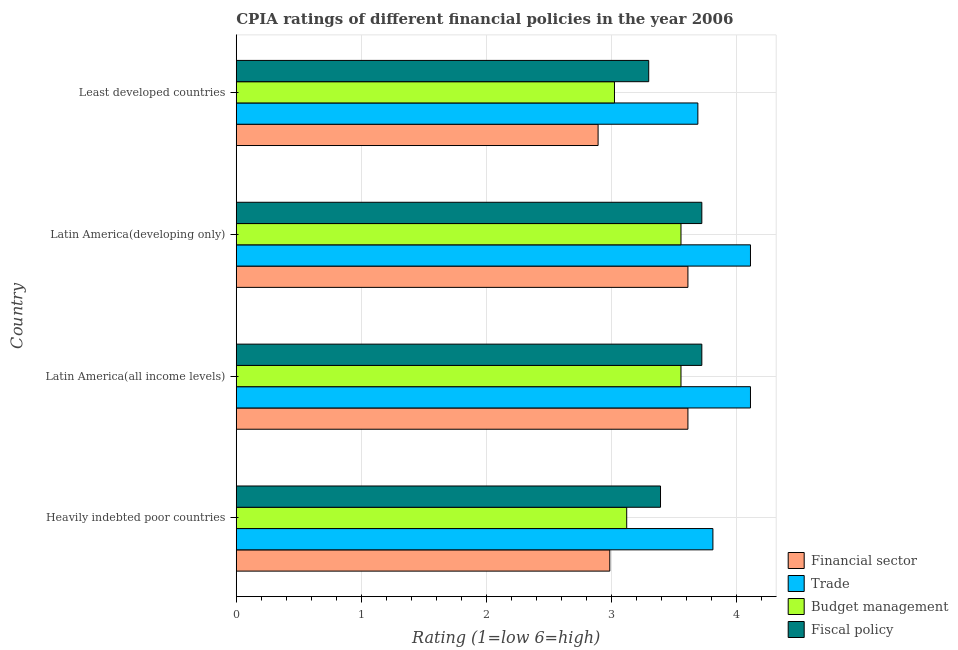How many bars are there on the 4th tick from the top?
Ensure brevity in your answer.  4. What is the label of the 3rd group of bars from the top?
Your answer should be compact. Latin America(all income levels). In how many cases, is the number of bars for a given country not equal to the number of legend labels?
Offer a terse response. 0. What is the cpia rating of trade in Heavily indebted poor countries?
Ensure brevity in your answer.  3.81. Across all countries, what is the maximum cpia rating of fiscal policy?
Your response must be concise. 3.72. Across all countries, what is the minimum cpia rating of financial sector?
Your response must be concise. 2.89. In which country was the cpia rating of trade maximum?
Your answer should be compact. Latin America(all income levels). In which country was the cpia rating of trade minimum?
Provide a succinct answer. Least developed countries. What is the total cpia rating of budget management in the graph?
Give a very brief answer. 13.26. What is the difference between the cpia rating of budget management in Heavily indebted poor countries and that in Latin America(developing only)?
Provide a succinct answer. -0.43. What is the difference between the cpia rating of fiscal policy in Least developed countries and the cpia rating of trade in Heavily indebted poor countries?
Your response must be concise. -0.51. What is the average cpia rating of financial sector per country?
Provide a short and direct response. 3.27. What is the difference between the cpia rating of financial sector and cpia rating of budget management in Latin America(all income levels)?
Give a very brief answer. 0.06. What is the ratio of the cpia rating of trade in Heavily indebted poor countries to that in Latin America(developing only)?
Ensure brevity in your answer.  0.93. Is the difference between the cpia rating of trade in Latin America(all income levels) and Least developed countries greater than the difference between the cpia rating of fiscal policy in Latin America(all income levels) and Least developed countries?
Your answer should be compact. No. What is the difference between the highest and the lowest cpia rating of trade?
Make the answer very short. 0.42. What does the 2nd bar from the top in Latin America(all income levels) represents?
Your answer should be compact. Budget management. What does the 1st bar from the bottom in Least developed countries represents?
Ensure brevity in your answer.  Financial sector. What is the difference between two consecutive major ticks on the X-axis?
Offer a very short reply. 1. Are the values on the major ticks of X-axis written in scientific E-notation?
Ensure brevity in your answer.  No. Does the graph contain any zero values?
Keep it short and to the point. No. Does the graph contain grids?
Ensure brevity in your answer.  Yes. How are the legend labels stacked?
Your answer should be compact. Vertical. What is the title of the graph?
Make the answer very short. CPIA ratings of different financial policies in the year 2006. Does "Water" appear as one of the legend labels in the graph?
Offer a very short reply. No. What is the label or title of the Y-axis?
Make the answer very short. Country. What is the Rating (1=low 6=high) of Financial sector in Heavily indebted poor countries?
Give a very brief answer. 2.99. What is the Rating (1=low 6=high) of Trade in Heavily indebted poor countries?
Provide a short and direct response. 3.81. What is the Rating (1=low 6=high) of Budget management in Heavily indebted poor countries?
Keep it short and to the point. 3.12. What is the Rating (1=low 6=high) in Fiscal policy in Heavily indebted poor countries?
Provide a short and direct response. 3.39. What is the Rating (1=low 6=high) in Financial sector in Latin America(all income levels)?
Give a very brief answer. 3.61. What is the Rating (1=low 6=high) of Trade in Latin America(all income levels)?
Your answer should be compact. 4.11. What is the Rating (1=low 6=high) in Budget management in Latin America(all income levels)?
Provide a short and direct response. 3.56. What is the Rating (1=low 6=high) in Fiscal policy in Latin America(all income levels)?
Provide a short and direct response. 3.72. What is the Rating (1=low 6=high) of Financial sector in Latin America(developing only)?
Offer a terse response. 3.61. What is the Rating (1=low 6=high) in Trade in Latin America(developing only)?
Offer a very short reply. 4.11. What is the Rating (1=low 6=high) in Budget management in Latin America(developing only)?
Keep it short and to the point. 3.56. What is the Rating (1=low 6=high) of Fiscal policy in Latin America(developing only)?
Your response must be concise. 3.72. What is the Rating (1=low 6=high) in Financial sector in Least developed countries?
Give a very brief answer. 2.89. What is the Rating (1=low 6=high) of Trade in Least developed countries?
Your response must be concise. 3.69. What is the Rating (1=low 6=high) of Budget management in Least developed countries?
Offer a very short reply. 3.02. What is the Rating (1=low 6=high) in Fiscal policy in Least developed countries?
Provide a short and direct response. 3.3. Across all countries, what is the maximum Rating (1=low 6=high) in Financial sector?
Provide a short and direct response. 3.61. Across all countries, what is the maximum Rating (1=low 6=high) in Trade?
Your response must be concise. 4.11. Across all countries, what is the maximum Rating (1=low 6=high) in Budget management?
Your answer should be very brief. 3.56. Across all countries, what is the maximum Rating (1=low 6=high) in Fiscal policy?
Your response must be concise. 3.72. Across all countries, what is the minimum Rating (1=low 6=high) in Financial sector?
Your answer should be very brief. 2.89. Across all countries, what is the minimum Rating (1=low 6=high) of Trade?
Make the answer very short. 3.69. Across all countries, what is the minimum Rating (1=low 6=high) in Budget management?
Your answer should be compact. 3.02. Across all countries, what is the minimum Rating (1=low 6=high) of Fiscal policy?
Keep it short and to the point. 3.3. What is the total Rating (1=low 6=high) in Financial sector in the graph?
Your answer should be very brief. 13.1. What is the total Rating (1=low 6=high) in Trade in the graph?
Offer a terse response. 15.72. What is the total Rating (1=low 6=high) of Budget management in the graph?
Offer a very short reply. 13.26. What is the total Rating (1=low 6=high) of Fiscal policy in the graph?
Make the answer very short. 14.13. What is the difference between the Rating (1=low 6=high) in Financial sector in Heavily indebted poor countries and that in Latin America(all income levels)?
Offer a terse response. -0.62. What is the difference between the Rating (1=low 6=high) in Trade in Heavily indebted poor countries and that in Latin America(all income levels)?
Provide a short and direct response. -0.3. What is the difference between the Rating (1=low 6=high) of Budget management in Heavily indebted poor countries and that in Latin America(all income levels)?
Your response must be concise. -0.43. What is the difference between the Rating (1=low 6=high) in Fiscal policy in Heavily indebted poor countries and that in Latin America(all income levels)?
Keep it short and to the point. -0.33. What is the difference between the Rating (1=low 6=high) of Financial sector in Heavily indebted poor countries and that in Latin America(developing only)?
Your response must be concise. -0.62. What is the difference between the Rating (1=low 6=high) of Trade in Heavily indebted poor countries and that in Latin America(developing only)?
Your answer should be very brief. -0.3. What is the difference between the Rating (1=low 6=high) of Budget management in Heavily indebted poor countries and that in Latin America(developing only)?
Provide a short and direct response. -0.43. What is the difference between the Rating (1=low 6=high) in Fiscal policy in Heavily indebted poor countries and that in Latin America(developing only)?
Offer a very short reply. -0.33. What is the difference between the Rating (1=low 6=high) of Financial sector in Heavily indebted poor countries and that in Least developed countries?
Keep it short and to the point. 0.09. What is the difference between the Rating (1=low 6=high) in Trade in Heavily indebted poor countries and that in Least developed countries?
Give a very brief answer. 0.12. What is the difference between the Rating (1=low 6=high) of Budget management in Heavily indebted poor countries and that in Least developed countries?
Provide a short and direct response. 0.1. What is the difference between the Rating (1=low 6=high) of Fiscal policy in Heavily indebted poor countries and that in Least developed countries?
Make the answer very short. 0.09. What is the difference between the Rating (1=low 6=high) of Financial sector in Latin America(all income levels) and that in Latin America(developing only)?
Make the answer very short. 0. What is the difference between the Rating (1=low 6=high) in Trade in Latin America(all income levels) and that in Latin America(developing only)?
Ensure brevity in your answer.  0. What is the difference between the Rating (1=low 6=high) in Budget management in Latin America(all income levels) and that in Latin America(developing only)?
Your answer should be very brief. 0. What is the difference between the Rating (1=low 6=high) in Financial sector in Latin America(all income levels) and that in Least developed countries?
Make the answer very short. 0.72. What is the difference between the Rating (1=low 6=high) in Trade in Latin America(all income levels) and that in Least developed countries?
Ensure brevity in your answer.  0.42. What is the difference between the Rating (1=low 6=high) of Budget management in Latin America(all income levels) and that in Least developed countries?
Your answer should be compact. 0.53. What is the difference between the Rating (1=low 6=high) of Fiscal policy in Latin America(all income levels) and that in Least developed countries?
Make the answer very short. 0.42. What is the difference between the Rating (1=low 6=high) in Financial sector in Latin America(developing only) and that in Least developed countries?
Keep it short and to the point. 0.72. What is the difference between the Rating (1=low 6=high) of Trade in Latin America(developing only) and that in Least developed countries?
Offer a very short reply. 0.42. What is the difference between the Rating (1=low 6=high) of Budget management in Latin America(developing only) and that in Least developed countries?
Keep it short and to the point. 0.53. What is the difference between the Rating (1=low 6=high) in Fiscal policy in Latin America(developing only) and that in Least developed countries?
Your answer should be very brief. 0.42. What is the difference between the Rating (1=low 6=high) of Financial sector in Heavily indebted poor countries and the Rating (1=low 6=high) of Trade in Latin America(all income levels)?
Your response must be concise. -1.12. What is the difference between the Rating (1=low 6=high) in Financial sector in Heavily indebted poor countries and the Rating (1=low 6=high) in Budget management in Latin America(all income levels)?
Offer a terse response. -0.57. What is the difference between the Rating (1=low 6=high) in Financial sector in Heavily indebted poor countries and the Rating (1=low 6=high) in Fiscal policy in Latin America(all income levels)?
Provide a short and direct response. -0.74. What is the difference between the Rating (1=low 6=high) in Trade in Heavily indebted poor countries and the Rating (1=low 6=high) in Budget management in Latin America(all income levels)?
Give a very brief answer. 0.26. What is the difference between the Rating (1=low 6=high) in Trade in Heavily indebted poor countries and the Rating (1=low 6=high) in Fiscal policy in Latin America(all income levels)?
Make the answer very short. 0.09. What is the difference between the Rating (1=low 6=high) in Budget management in Heavily indebted poor countries and the Rating (1=low 6=high) in Fiscal policy in Latin America(all income levels)?
Offer a very short reply. -0.6. What is the difference between the Rating (1=low 6=high) in Financial sector in Heavily indebted poor countries and the Rating (1=low 6=high) in Trade in Latin America(developing only)?
Make the answer very short. -1.12. What is the difference between the Rating (1=low 6=high) in Financial sector in Heavily indebted poor countries and the Rating (1=low 6=high) in Budget management in Latin America(developing only)?
Your response must be concise. -0.57. What is the difference between the Rating (1=low 6=high) of Financial sector in Heavily indebted poor countries and the Rating (1=low 6=high) of Fiscal policy in Latin America(developing only)?
Provide a succinct answer. -0.74. What is the difference between the Rating (1=low 6=high) of Trade in Heavily indebted poor countries and the Rating (1=low 6=high) of Budget management in Latin America(developing only)?
Your response must be concise. 0.26. What is the difference between the Rating (1=low 6=high) of Trade in Heavily indebted poor countries and the Rating (1=low 6=high) of Fiscal policy in Latin America(developing only)?
Ensure brevity in your answer.  0.09. What is the difference between the Rating (1=low 6=high) of Budget management in Heavily indebted poor countries and the Rating (1=low 6=high) of Fiscal policy in Latin America(developing only)?
Keep it short and to the point. -0.6. What is the difference between the Rating (1=low 6=high) in Financial sector in Heavily indebted poor countries and the Rating (1=low 6=high) in Trade in Least developed countries?
Your answer should be very brief. -0.7. What is the difference between the Rating (1=low 6=high) of Financial sector in Heavily indebted poor countries and the Rating (1=low 6=high) of Budget management in Least developed countries?
Provide a succinct answer. -0.04. What is the difference between the Rating (1=low 6=high) of Financial sector in Heavily indebted poor countries and the Rating (1=low 6=high) of Fiscal policy in Least developed countries?
Give a very brief answer. -0.31. What is the difference between the Rating (1=low 6=high) in Trade in Heavily indebted poor countries and the Rating (1=low 6=high) in Budget management in Least developed countries?
Your response must be concise. 0.79. What is the difference between the Rating (1=low 6=high) of Trade in Heavily indebted poor countries and the Rating (1=low 6=high) of Fiscal policy in Least developed countries?
Provide a succinct answer. 0.51. What is the difference between the Rating (1=low 6=high) of Budget management in Heavily indebted poor countries and the Rating (1=low 6=high) of Fiscal policy in Least developed countries?
Provide a succinct answer. -0.18. What is the difference between the Rating (1=low 6=high) in Financial sector in Latin America(all income levels) and the Rating (1=low 6=high) in Trade in Latin America(developing only)?
Your answer should be compact. -0.5. What is the difference between the Rating (1=low 6=high) of Financial sector in Latin America(all income levels) and the Rating (1=low 6=high) of Budget management in Latin America(developing only)?
Your response must be concise. 0.06. What is the difference between the Rating (1=low 6=high) in Financial sector in Latin America(all income levels) and the Rating (1=low 6=high) in Fiscal policy in Latin America(developing only)?
Offer a very short reply. -0.11. What is the difference between the Rating (1=low 6=high) of Trade in Latin America(all income levels) and the Rating (1=low 6=high) of Budget management in Latin America(developing only)?
Provide a short and direct response. 0.56. What is the difference between the Rating (1=low 6=high) in Trade in Latin America(all income levels) and the Rating (1=low 6=high) in Fiscal policy in Latin America(developing only)?
Your answer should be very brief. 0.39. What is the difference between the Rating (1=low 6=high) of Financial sector in Latin America(all income levels) and the Rating (1=low 6=high) of Trade in Least developed countries?
Your response must be concise. -0.08. What is the difference between the Rating (1=low 6=high) of Financial sector in Latin America(all income levels) and the Rating (1=low 6=high) of Budget management in Least developed countries?
Keep it short and to the point. 0.59. What is the difference between the Rating (1=low 6=high) in Financial sector in Latin America(all income levels) and the Rating (1=low 6=high) in Fiscal policy in Least developed countries?
Your response must be concise. 0.31. What is the difference between the Rating (1=low 6=high) of Trade in Latin America(all income levels) and the Rating (1=low 6=high) of Budget management in Least developed countries?
Offer a very short reply. 1.09. What is the difference between the Rating (1=low 6=high) of Trade in Latin America(all income levels) and the Rating (1=low 6=high) of Fiscal policy in Least developed countries?
Offer a very short reply. 0.81. What is the difference between the Rating (1=low 6=high) in Budget management in Latin America(all income levels) and the Rating (1=low 6=high) in Fiscal policy in Least developed countries?
Provide a short and direct response. 0.26. What is the difference between the Rating (1=low 6=high) of Financial sector in Latin America(developing only) and the Rating (1=low 6=high) of Trade in Least developed countries?
Ensure brevity in your answer.  -0.08. What is the difference between the Rating (1=low 6=high) in Financial sector in Latin America(developing only) and the Rating (1=low 6=high) in Budget management in Least developed countries?
Offer a very short reply. 0.59. What is the difference between the Rating (1=low 6=high) of Financial sector in Latin America(developing only) and the Rating (1=low 6=high) of Fiscal policy in Least developed countries?
Your answer should be very brief. 0.31. What is the difference between the Rating (1=low 6=high) of Trade in Latin America(developing only) and the Rating (1=low 6=high) of Budget management in Least developed countries?
Provide a succinct answer. 1.09. What is the difference between the Rating (1=low 6=high) in Trade in Latin America(developing only) and the Rating (1=low 6=high) in Fiscal policy in Least developed countries?
Provide a succinct answer. 0.81. What is the difference between the Rating (1=low 6=high) in Budget management in Latin America(developing only) and the Rating (1=low 6=high) in Fiscal policy in Least developed countries?
Your answer should be compact. 0.26. What is the average Rating (1=low 6=high) in Financial sector per country?
Give a very brief answer. 3.28. What is the average Rating (1=low 6=high) in Trade per country?
Offer a very short reply. 3.93. What is the average Rating (1=low 6=high) of Budget management per country?
Give a very brief answer. 3.31. What is the average Rating (1=low 6=high) in Fiscal policy per country?
Your answer should be very brief. 3.53. What is the difference between the Rating (1=low 6=high) in Financial sector and Rating (1=low 6=high) in Trade in Heavily indebted poor countries?
Your answer should be very brief. -0.82. What is the difference between the Rating (1=low 6=high) in Financial sector and Rating (1=low 6=high) in Budget management in Heavily indebted poor countries?
Make the answer very short. -0.14. What is the difference between the Rating (1=low 6=high) of Financial sector and Rating (1=low 6=high) of Fiscal policy in Heavily indebted poor countries?
Provide a succinct answer. -0.41. What is the difference between the Rating (1=low 6=high) of Trade and Rating (1=low 6=high) of Budget management in Heavily indebted poor countries?
Your answer should be very brief. 0.69. What is the difference between the Rating (1=low 6=high) of Trade and Rating (1=low 6=high) of Fiscal policy in Heavily indebted poor countries?
Offer a very short reply. 0.42. What is the difference between the Rating (1=low 6=high) of Budget management and Rating (1=low 6=high) of Fiscal policy in Heavily indebted poor countries?
Ensure brevity in your answer.  -0.27. What is the difference between the Rating (1=low 6=high) of Financial sector and Rating (1=low 6=high) of Trade in Latin America(all income levels)?
Make the answer very short. -0.5. What is the difference between the Rating (1=low 6=high) in Financial sector and Rating (1=low 6=high) in Budget management in Latin America(all income levels)?
Ensure brevity in your answer.  0.06. What is the difference between the Rating (1=low 6=high) in Financial sector and Rating (1=low 6=high) in Fiscal policy in Latin America(all income levels)?
Make the answer very short. -0.11. What is the difference between the Rating (1=low 6=high) of Trade and Rating (1=low 6=high) of Budget management in Latin America(all income levels)?
Keep it short and to the point. 0.56. What is the difference between the Rating (1=low 6=high) in Trade and Rating (1=low 6=high) in Fiscal policy in Latin America(all income levels)?
Provide a short and direct response. 0.39. What is the difference between the Rating (1=low 6=high) in Budget management and Rating (1=low 6=high) in Fiscal policy in Latin America(all income levels)?
Ensure brevity in your answer.  -0.17. What is the difference between the Rating (1=low 6=high) of Financial sector and Rating (1=low 6=high) of Trade in Latin America(developing only)?
Provide a short and direct response. -0.5. What is the difference between the Rating (1=low 6=high) in Financial sector and Rating (1=low 6=high) in Budget management in Latin America(developing only)?
Give a very brief answer. 0.06. What is the difference between the Rating (1=low 6=high) in Financial sector and Rating (1=low 6=high) in Fiscal policy in Latin America(developing only)?
Give a very brief answer. -0.11. What is the difference between the Rating (1=low 6=high) in Trade and Rating (1=low 6=high) in Budget management in Latin America(developing only)?
Provide a short and direct response. 0.56. What is the difference between the Rating (1=low 6=high) in Trade and Rating (1=low 6=high) in Fiscal policy in Latin America(developing only)?
Ensure brevity in your answer.  0.39. What is the difference between the Rating (1=low 6=high) of Budget management and Rating (1=low 6=high) of Fiscal policy in Latin America(developing only)?
Give a very brief answer. -0.17. What is the difference between the Rating (1=low 6=high) in Financial sector and Rating (1=low 6=high) in Trade in Least developed countries?
Make the answer very short. -0.8. What is the difference between the Rating (1=low 6=high) in Financial sector and Rating (1=low 6=high) in Budget management in Least developed countries?
Make the answer very short. -0.13. What is the difference between the Rating (1=low 6=high) of Financial sector and Rating (1=low 6=high) of Fiscal policy in Least developed countries?
Provide a short and direct response. -0.4. What is the difference between the Rating (1=low 6=high) in Trade and Rating (1=low 6=high) in Fiscal policy in Least developed countries?
Your answer should be compact. 0.39. What is the difference between the Rating (1=low 6=high) in Budget management and Rating (1=low 6=high) in Fiscal policy in Least developed countries?
Provide a short and direct response. -0.27. What is the ratio of the Rating (1=low 6=high) in Financial sector in Heavily indebted poor countries to that in Latin America(all income levels)?
Your response must be concise. 0.83. What is the ratio of the Rating (1=low 6=high) of Trade in Heavily indebted poor countries to that in Latin America(all income levels)?
Your answer should be compact. 0.93. What is the ratio of the Rating (1=low 6=high) in Budget management in Heavily indebted poor countries to that in Latin America(all income levels)?
Keep it short and to the point. 0.88. What is the ratio of the Rating (1=low 6=high) in Fiscal policy in Heavily indebted poor countries to that in Latin America(all income levels)?
Provide a succinct answer. 0.91. What is the ratio of the Rating (1=low 6=high) of Financial sector in Heavily indebted poor countries to that in Latin America(developing only)?
Your answer should be compact. 0.83. What is the ratio of the Rating (1=low 6=high) in Trade in Heavily indebted poor countries to that in Latin America(developing only)?
Keep it short and to the point. 0.93. What is the ratio of the Rating (1=low 6=high) of Budget management in Heavily indebted poor countries to that in Latin America(developing only)?
Keep it short and to the point. 0.88. What is the ratio of the Rating (1=low 6=high) of Fiscal policy in Heavily indebted poor countries to that in Latin America(developing only)?
Provide a succinct answer. 0.91. What is the ratio of the Rating (1=low 6=high) of Financial sector in Heavily indebted poor countries to that in Least developed countries?
Your response must be concise. 1.03. What is the ratio of the Rating (1=low 6=high) of Trade in Heavily indebted poor countries to that in Least developed countries?
Offer a terse response. 1.03. What is the ratio of the Rating (1=low 6=high) of Budget management in Heavily indebted poor countries to that in Least developed countries?
Offer a very short reply. 1.03. What is the ratio of the Rating (1=low 6=high) in Fiscal policy in Heavily indebted poor countries to that in Least developed countries?
Your response must be concise. 1.03. What is the ratio of the Rating (1=low 6=high) in Financial sector in Latin America(all income levels) to that in Latin America(developing only)?
Offer a terse response. 1. What is the ratio of the Rating (1=low 6=high) in Trade in Latin America(all income levels) to that in Latin America(developing only)?
Provide a short and direct response. 1. What is the ratio of the Rating (1=low 6=high) of Fiscal policy in Latin America(all income levels) to that in Latin America(developing only)?
Your answer should be compact. 1. What is the ratio of the Rating (1=low 6=high) of Financial sector in Latin America(all income levels) to that in Least developed countries?
Make the answer very short. 1.25. What is the ratio of the Rating (1=low 6=high) of Trade in Latin America(all income levels) to that in Least developed countries?
Provide a short and direct response. 1.11. What is the ratio of the Rating (1=low 6=high) in Budget management in Latin America(all income levels) to that in Least developed countries?
Give a very brief answer. 1.18. What is the ratio of the Rating (1=low 6=high) in Fiscal policy in Latin America(all income levels) to that in Least developed countries?
Your answer should be very brief. 1.13. What is the ratio of the Rating (1=low 6=high) in Financial sector in Latin America(developing only) to that in Least developed countries?
Keep it short and to the point. 1.25. What is the ratio of the Rating (1=low 6=high) in Trade in Latin America(developing only) to that in Least developed countries?
Provide a short and direct response. 1.11. What is the ratio of the Rating (1=low 6=high) of Budget management in Latin America(developing only) to that in Least developed countries?
Provide a succinct answer. 1.18. What is the ratio of the Rating (1=low 6=high) in Fiscal policy in Latin America(developing only) to that in Least developed countries?
Your answer should be very brief. 1.13. What is the difference between the highest and the second highest Rating (1=low 6=high) of Trade?
Keep it short and to the point. 0. What is the difference between the highest and the second highest Rating (1=low 6=high) in Budget management?
Your answer should be very brief. 0. What is the difference between the highest and the lowest Rating (1=low 6=high) of Financial sector?
Offer a very short reply. 0.72. What is the difference between the highest and the lowest Rating (1=low 6=high) in Trade?
Provide a succinct answer. 0.42. What is the difference between the highest and the lowest Rating (1=low 6=high) in Budget management?
Provide a short and direct response. 0.53. What is the difference between the highest and the lowest Rating (1=low 6=high) of Fiscal policy?
Your response must be concise. 0.42. 